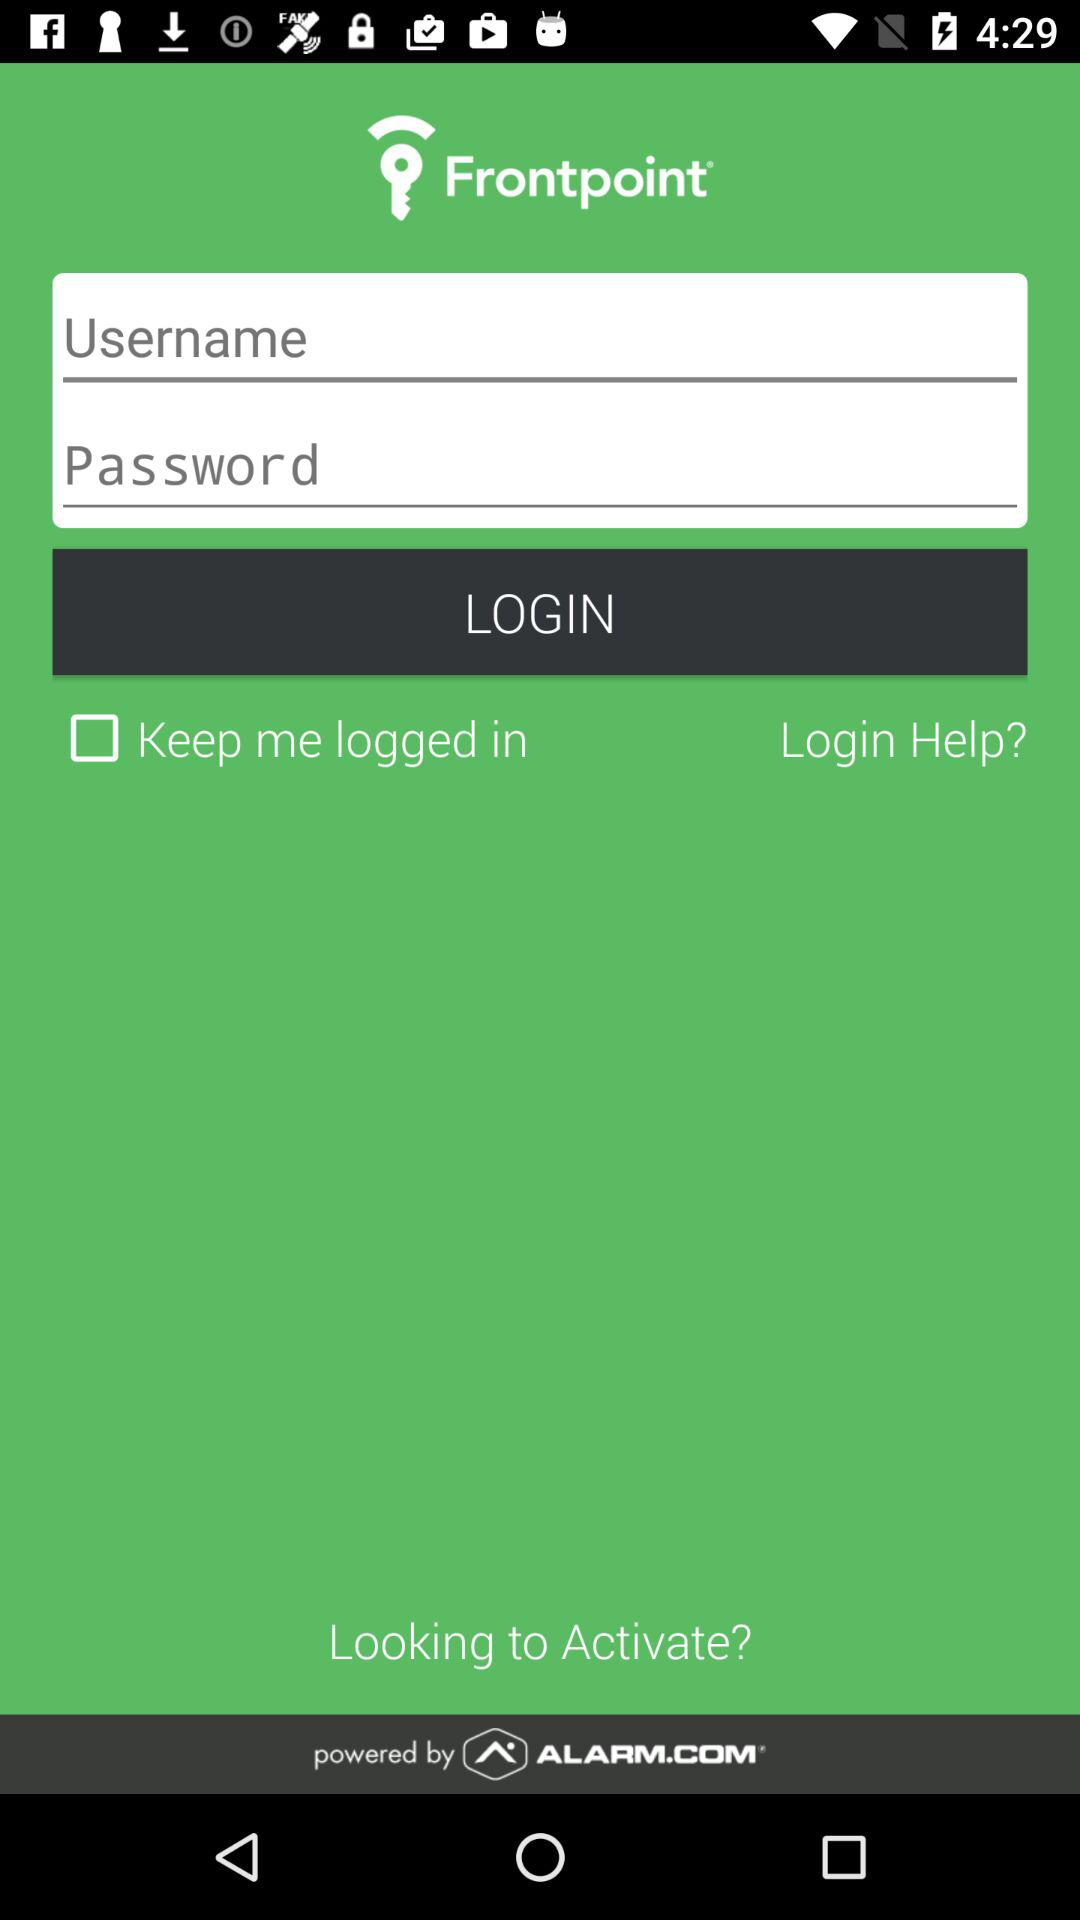What's the status of "Keep me logged in"? The status is off. 